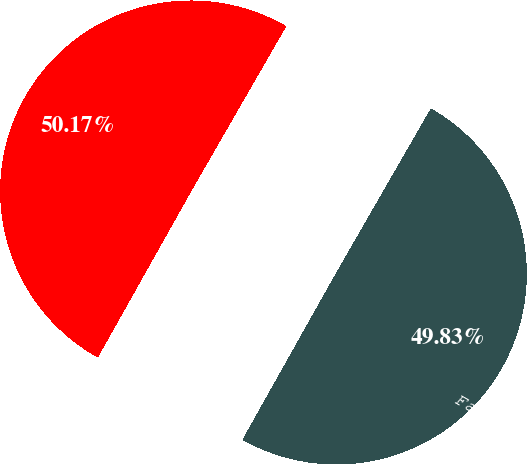Convert chart to OTSL. <chart><loc_0><loc_0><loc_500><loc_500><pie_chart><fcel>Facility exit costs<fcel>Total accrual<nl><fcel>49.83%<fcel>50.17%<nl></chart> 